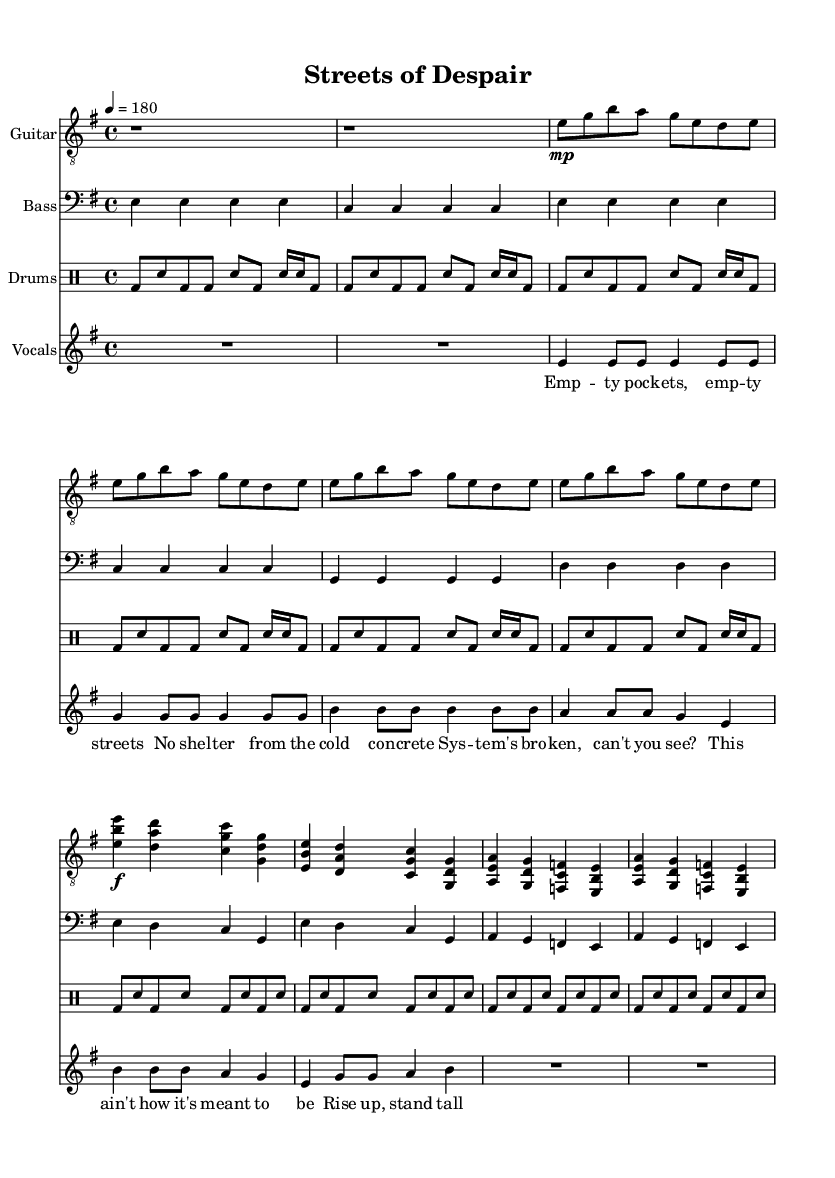What is the key signature of this music? The key signature is indicated near the beginning of the sheet music. It shows that there is one sharp (F#), which means the key is E minor.
Answer: E minor What is the time signature of this music? The time signature is located at the beginning of the sheet music as well. It is shown as 4/4, which indicates four beats per measure and a quarter note gets one beat.
Answer: 4/4 What is the tempo marking of this music? The tempo marking is found near the beginning of the score. It states "4 = 180," meaning the quarter note gets a tempo of 180 beats per minute.
Answer: 180 How many measures are in the verse? To determine the number of measures, I count the measures in the "Verse 1" section of the sheet music. There are 4 measures in the verse.
Answer: 4 What is the main theme of the lyrics? The lyrics reflect themes of social injustice, highlighting poverty and systemic issues. By analyzing the words, we see references to empty pockets and lack of shelter.
Answer: Social injustice What chord progression is used in the chorus? By examining the notes in the "Chorus" section, we see the following chords: E major, D major, C major, and G major. This indicates a common punk rock chord progression that creates an uplifting yet defiant sound.
Answer: E D C G What type of musical dynamics are present in the chorus? The dynamics in the chorus indicate a forte (loud) section, marked with the symbol "f." This intensifies the emotional impact of the lyrics.
Answer: Forte 